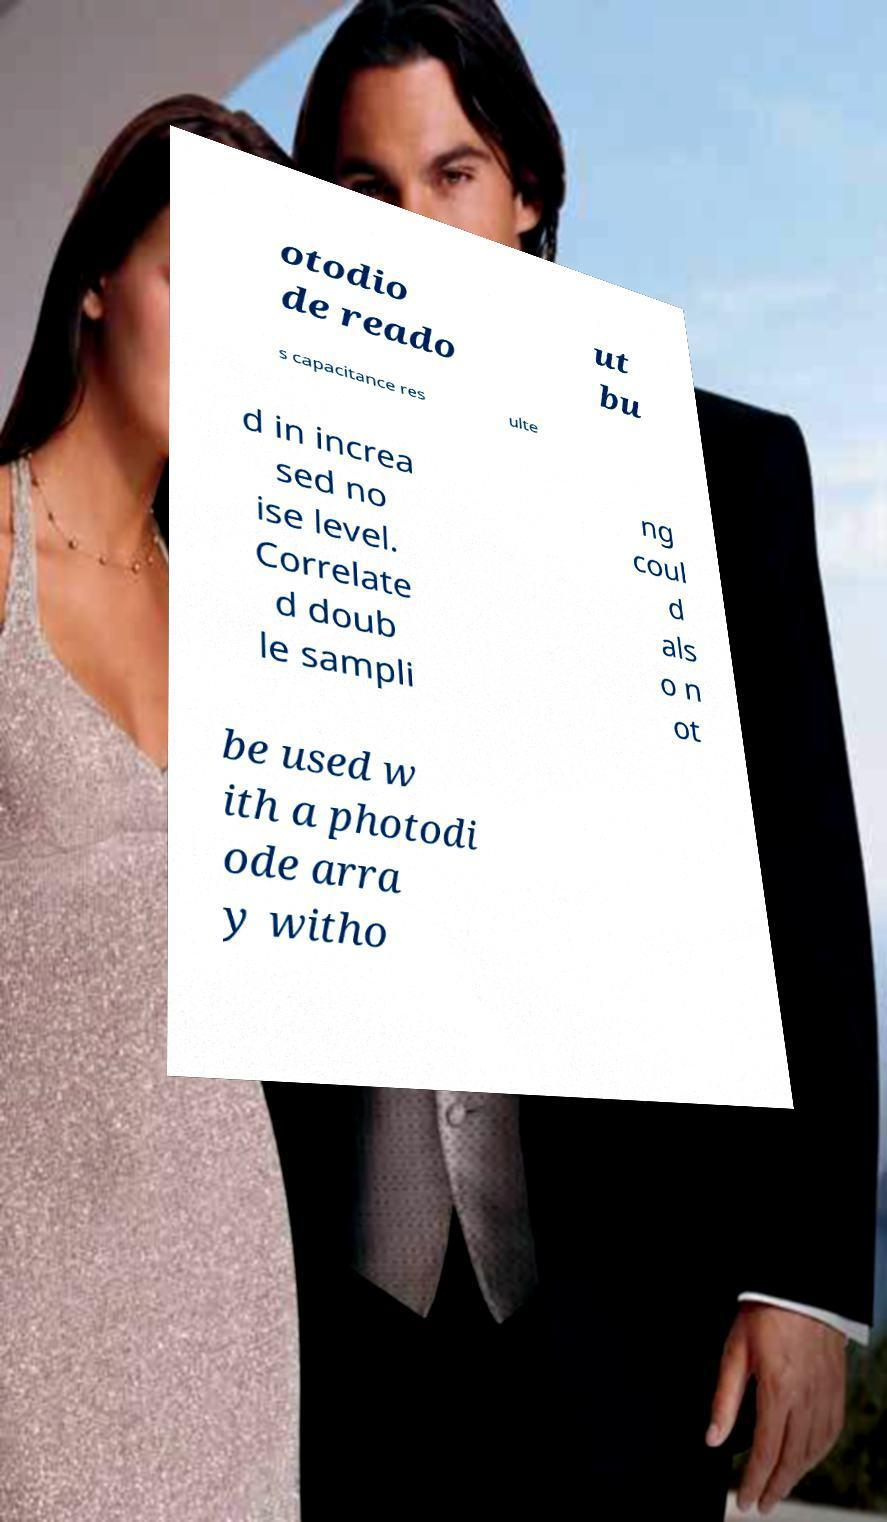Could you extract and type out the text from this image? otodio de reado ut bu s capacitance res ulte d in increa sed no ise level. Correlate d doub le sampli ng coul d als o n ot be used w ith a photodi ode arra y witho 